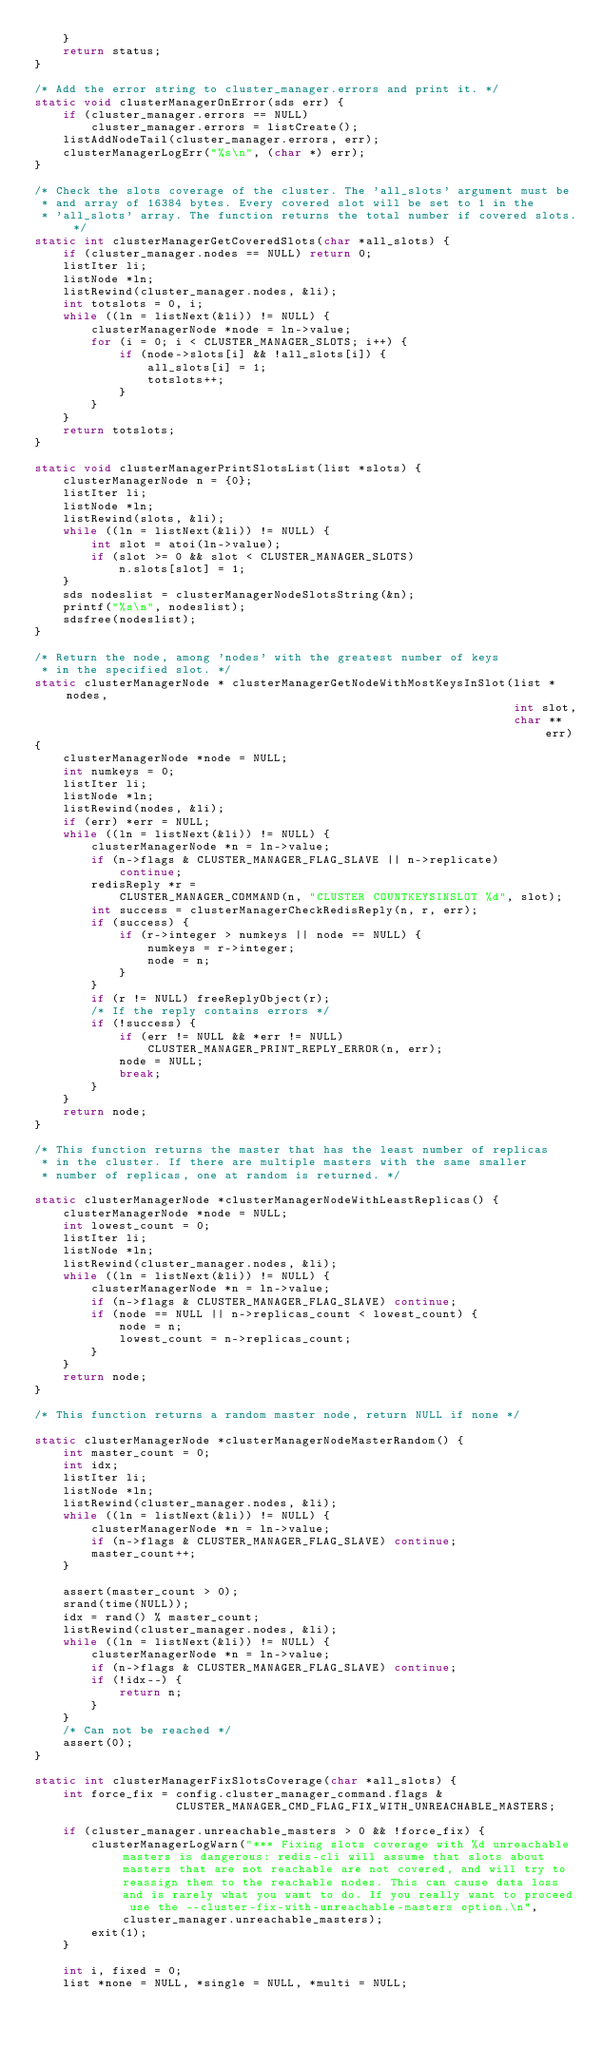Convert code to text. <code><loc_0><loc_0><loc_500><loc_500><_C_>    }
    return status;
}

/* Add the error string to cluster_manager.errors and print it. */
static void clusterManagerOnError(sds err) {
    if (cluster_manager.errors == NULL)
        cluster_manager.errors = listCreate();
    listAddNodeTail(cluster_manager.errors, err);
    clusterManagerLogErr("%s\n", (char *) err);
}

/* Check the slots coverage of the cluster. The 'all_slots' argument must be
 * and array of 16384 bytes. Every covered slot will be set to 1 in the
 * 'all_slots' array. The function returns the total number if covered slots.*/
static int clusterManagerGetCoveredSlots(char *all_slots) {
    if (cluster_manager.nodes == NULL) return 0;
    listIter li;
    listNode *ln;
    listRewind(cluster_manager.nodes, &li);
    int totslots = 0, i;
    while ((ln = listNext(&li)) != NULL) {
        clusterManagerNode *node = ln->value;
        for (i = 0; i < CLUSTER_MANAGER_SLOTS; i++) {
            if (node->slots[i] && !all_slots[i]) {
                all_slots[i] = 1;
                totslots++;
            }
        }
    }
    return totslots;
}

static void clusterManagerPrintSlotsList(list *slots) {
    clusterManagerNode n = {0};
    listIter li;
    listNode *ln;
    listRewind(slots, &li);
    while ((ln = listNext(&li)) != NULL) {
        int slot = atoi(ln->value);
        if (slot >= 0 && slot < CLUSTER_MANAGER_SLOTS)
            n.slots[slot] = 1;
    }
    sds nodeslist = clusterManagerNodeSlotsString(&n);
    printf("%s\n", nodeslist);
    sdsfree(nodeslist);
}

/* Return the node, among 'nodes' with the greatest number of keys
 * in the specified slot. */
static clusterManagerNode * clusterManagerGetNodeWithMostKeysInSlot(list *nodes,
                                                                    int slot,
                                                                    char **err)
{
    clusterManagerNode *node = NULL;
    int numkeys = 0;
    listIter li;
    listNode *ln;
    listRewind(nodes, &li);
    if (err) *err = NULL;
    while ((ln = listNext(&li)) != NULL) {
        clusterManagerNode *n = ln->value;
        if (n->flags & CLUSTER_MANAGER_FLAG_SLAVE || n->replicate)
            continue;
        redisReply *r =
            CLUSTER_MANAGER_COMMAND(n, "CLUSTER COUNTKEYSINSLOT %d", slot);
        int success = clusterManagerCheckRedisReply(n, r, err);
        if (success) {
            if (r->integer > numkeys || node == NULL) {
                numkeys = r->integer;
                node = n;
            }
        }
        if (r != NULL) freeReplyObject(r);
        /* If the reply contains errors */
        if (!success) {
            if (err != NULL && *err != NULL)
                CLUSTER_MANAGER_PRINT_REPLY_ERROR(n, err);
            node = NULL;
            break;
        }
    }
    return node;
}

/* This function returns the master that has the least number of replicas
 * in the cluster. If there are multiple masters with the same smaller
 * number of replicas, one at random is returned. */

static clusterManagerNode *clusterManagerNodeWithLeastReplicas() {
    clusterManagerNode *node = NULL;
    int lowest_count = 0;
    listIter li;
    listNode *ln;
    listRewind(cluster_manager.nodes, &li);
    while ((ln = listNext(&li)) != NULL) {
        clusterManagerNode *n = ln->value;
        if (n->flags & CLUSTER_MANAGER_FLAG_SLAVE) continue;
        if (node == NULL || n->replicas_count < lowest_count) {
            node = n;
            lowest_count = n->replicas_count;
        }
    }
    return node;
}

/* This function returns a random master node, return NULL if none */

static clusterManagerNode *clusterManagerNodeMasterRandom() {
    int master_count = 0;
    int idx;
    listIter li;
    listNode *ln;
    listRewind(cluster_manager.nodes, &li);
    while ((ln = listNext(&li)) != NULL) {
        clusterManagerNode *n = ln->value;
        if (n->flags & CLUSTER_MANAGER_FLAG_SLAVE) continue;
        master_count++;
    }

    assert(master_count > 0);
    srand(time(NULL));
    idx = rand() % master_count;
    listRewind(cluster_manager.nodes, &li);
    while ((ln = listNext(&li)) != NULL) {
        clusterManagerNode *n = ln->value;
        if (n->flags & CLUSTER_MANAGER_FLAG_SLAVE) continue;
        if (!idx--) {
            return n;
        }
    }
    /* Can not be reached */
    assert(0);
}

static int clusterManagerFixSlotsCoverage(char *all_slots) {
    int force_fix = config.cluster_manager_command.flags &
                    CLUSTER_MANAGER_CMD_FLAG_FIX_WITH_UNREACHABLE_MASTERS;

    if (cluster_manager.unreachable_masters > 0 && !force_fix) {
        clusterManagerLogWarn("*** Fixing slots coverage with %d unreachable masters is dangerous: redis-cli will assume that slots about masters that are not reachable are not covered, and will try to reassign them to the reachable nodes. This can cause data loss and is rarely what you want to do. If you really want to proceed use the --cluster-fix-with-unreachable-masters option.\n", cluster_manager.unreachable_masters);
        exit(1);
    }

    int i, fixed = 0;
    list *none = NULL, *single = NULL, *multi = NULL;</code> 